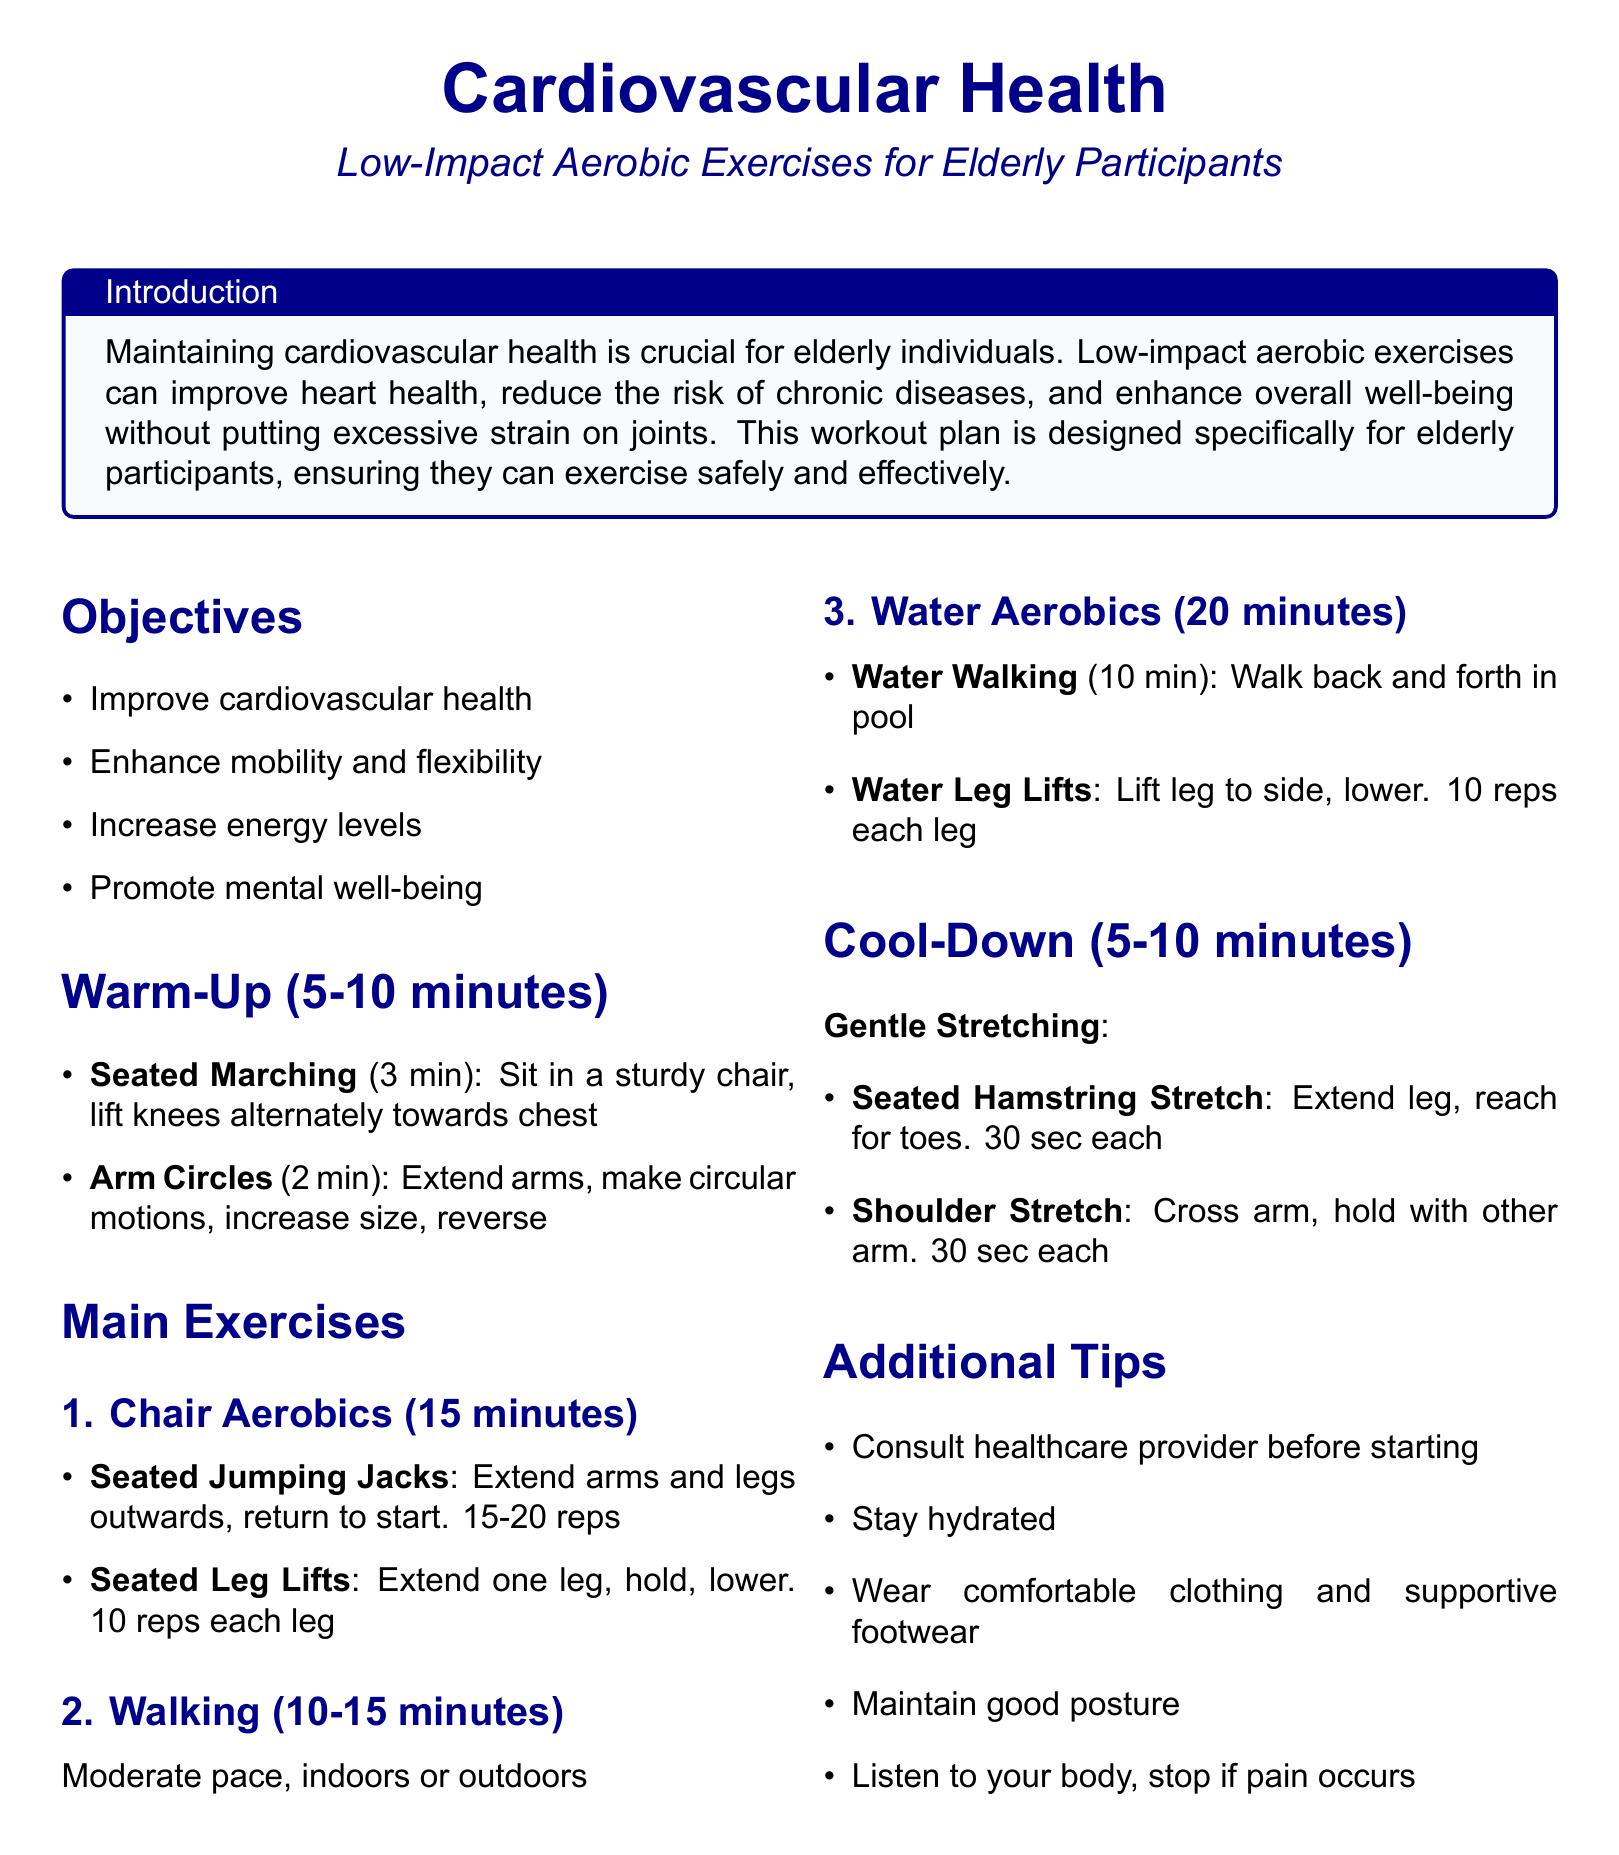What is the title of the document? The title is typically found at the top section of the document, presented in a large font.
Answer: Cardiovascular Health What are the main objectives of the workout plan? The main objectives can be located in the section listed as Objectives.
Answer: Improve cardiovascular health, enhance mobility and flexibility, increase energy levels, promote mental well-being How long should the warm-up last? The duration of the warm-up is stated in the Warm-Up section of the document.
Answer: 5-10 minutes What exercise is recommended for the cool-down? The cool-down section lists specific exercises to perform, which can be found in that section.
Answer: Gentle Stretching How many minutes is the Chair Aerobics exercise? The duration of Chair Aerobics is specified under the Main Exercises section.
Answer: 15 minutes What should elderly participants wear while exercising? This information is included in the Additional Tips section for guidelines on preparing for exercise.
Answer: Comfortable clothing and supportive footwear How many repetitions are suggested for Seated Jumping Jacks? The number of repetitions is provided as part of the exercise description in the main exercises.
Answer: 15-20 reps What should participants do if they experience pain? This important information is included in the Additional Tips section for safety during exercise.
Answer: Stop if pain occurs 